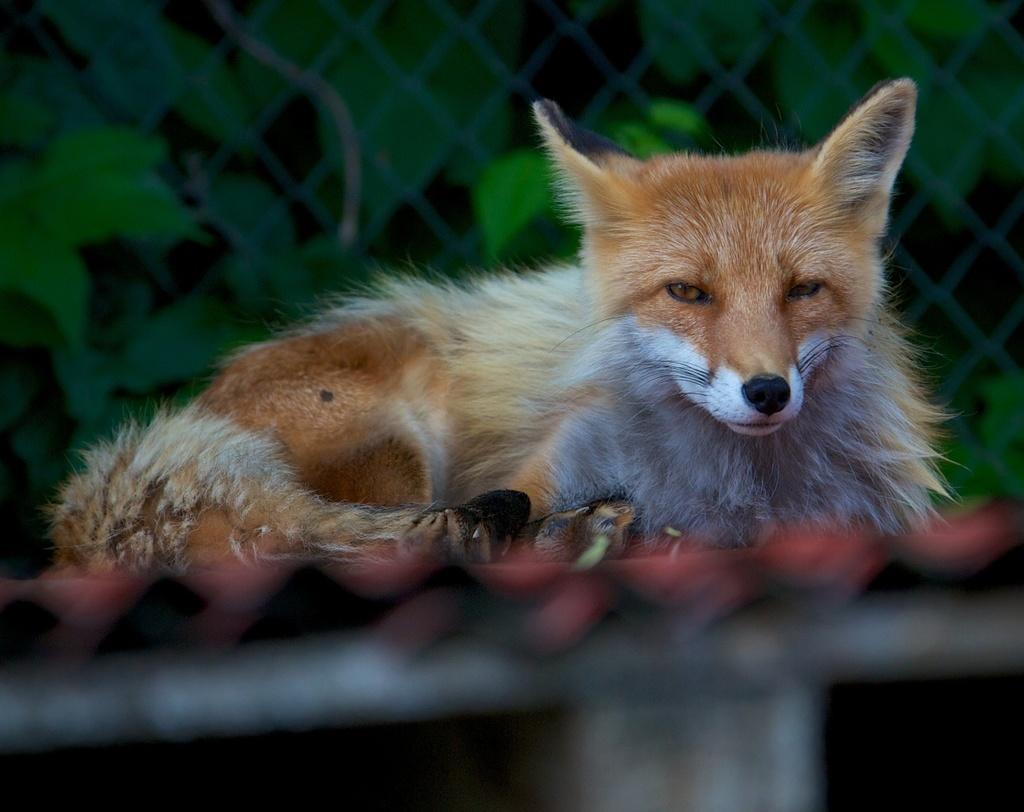Can you describe this image briefly? In this image I can see a dog and I can see a fence visible back side of the dog. 